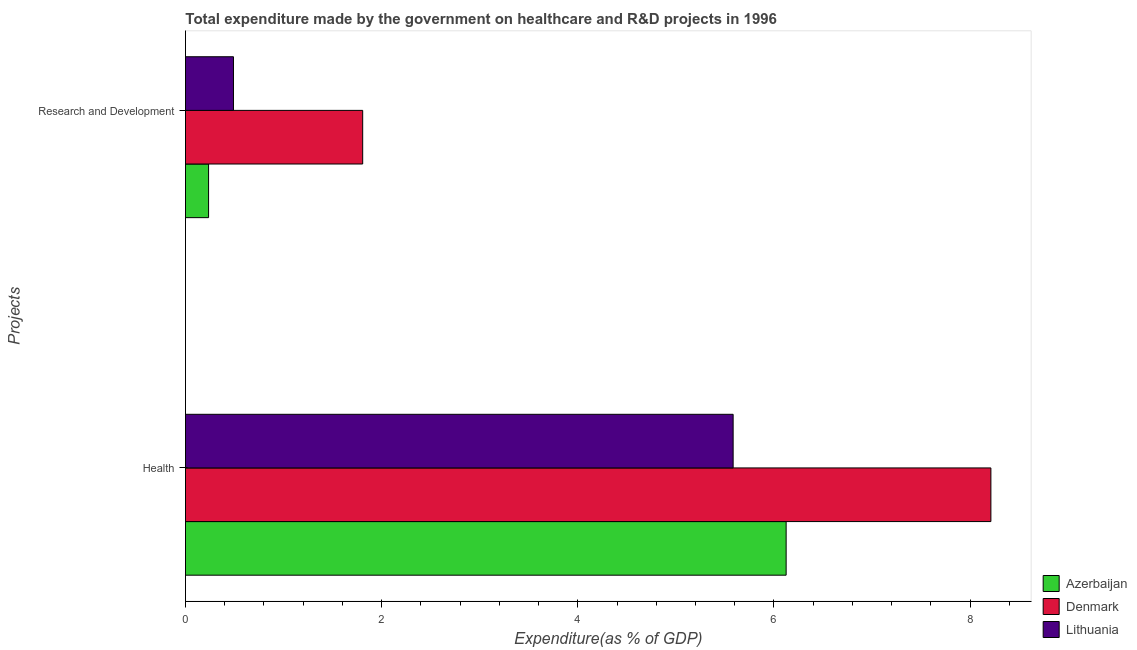How many different coloured bars are there?
Offer a very short reply. 3. Are the number of bars per tick equal to the number of legend labels?
Offer a very short reply. Yes. What is the label of the 2nd group of bars from the top?
Offer a very short reply. Health. What is the expenditure in r&d in Azerbaijan?
Offer a terse response. 0.24. Across all countries, what is the maximum expenditure in r&d?
Your answer should be compact. 1.81. Across all countries, what is the minimum expenditure in healthcare?
Provide a short and direct response. 5.58. In which country was the expenditure in healthcare maximum?
Make the answer very short. Denmark. In which country was the expenditure in r&d minimum?
Your answer should be compact. Azerbaijan. What is the total expenditure in r&d in the graph?
Your answer should be compact. 2.53. What is the difference between the expenditure in r&d in Lithuania and that in Azerbaijan?
Offer a terse response. 0.25. What is the difference between the expenditure in r&d in Lithuania and the expenditure in healthcare in Azerbaijan?
Your answer should be compact. -5.63. What is the average expenditure in r&d per country?
Provide a succinct answer. 0.84. What is the difference between the expenditure in r&d and expenditure in healthcare in Lithuania?
Keep it short and to the point. -5.09. In how many countries, is the expenditure in r&d greater than 2.8 %?
Your answer should be compact. 0. What is the ratio of the expenditure in r&d in Azerbaijan to that in Lithuania?
Your answer should be compact. 0.48. Is the expenditure in r&d in Denmark less than that in Azerbaijan?
Keep it short and to the point. No. In how many countries, is the expenditure in healthcare greater than the average expenditure in healthcare taken over all countries?
Your answer should be compact. 1. What does the 1st bar from the top in Health represents?
Your response must be concise. Lithuania. What is the difference between two consecutive major ticks on the X-axis?
Your answer should be compact. 2. Does the graph contain grids?
Give a very brief answer. No. Where does the legend appear in the graph?
Your answer should be compact. Bottom right. How many legend labels are there?
Keep it short and to the point. 3. How are the legend labels stacked?
Your answer should be very brief. Vertical. What is the title of the graph?
Provide a short and direct response. Total expenditure made by the government on healthcare and R&D projects in 1996. Does "Peru" appear as one of the legend labels in the graph?
Your answer should be compact. No. What is the label or title of the X-axis?
Your answer should be very brief. Expenditure(as % of GDP). What is the label or title of the Y-axis?
Ensure brevity in your answer.  Projects. What is the Expenditure(as % of GDP) in Azerbaijan in Health?
Provide a succinct answer. 6.12. What is the Expenditure(as % of GDP) in Denmark in Health?
Provide a short and direct response. 8.21. What is the Expenditure(as % of GDP) of Lithuania in Health?
Keep it short and to the point. 5.58. What is the Expenditure(as % of GDP) in Azerbaijan in Research and Development?
Provide a short and direct response. 0.24. What is the Expenditure(as % of GDP) of Denmark in Research and Development?
Give a very brief answer. 1.81. What is the Expenditure(as % of GDP) in Lithuania in Research and Development?
Provide a short and direct response. 0.49. Across all Projects, what is the maximum Expenditure(as % of GDP) in Azerbaijan?
Provide a short and direct response. 6.12. Across all Projects, what is the maximum Expenditure(as % of GDP) in Denmark?
Make the answer very short. 8.21. Across all Projects, what is the maximum Expenditure(as % of GDP) in Lithuania?
Make the answer very short. 5.58. Across all Projects, what is the minimum Expenditure(as % of GDP) in Azerbaijan?
Your response must be concise. 0.24. Across all Projects, what is the minimum Expenditure(as % of GDP) in Denmark?
Your answer should be compact. 1.81. Across all Projects, what is the minimum Expenditure(as % of GDP) in Lithuania?
Your answer should be very brief. 0.49. What is the total Expenditure(as % of GDP) in Azerbaijan in the graph?
Your response must be concise. 6.36. What is the total Expenditure(as % of GDP) of Denmark in the graph?
Offer a terse response. 10.02. What is the total Expenditure(as % of GDP) in Lithuania in the graph?
Provide a short and direct response. 6.07. What is the difference between the Expenditure(as % of GDP) in Azerbaijan in Health and that in Research and Development?
Your answer should be very brief. 5.89. What is the difference between the Expenditure(as % of GDP) in Denmark in Health and that in Research and Development?
Your answer should be compact. 6.4. What is the difference between the Expenditure(as % of GDP) in Lithuania in Health and that in Research and Development?
Provide a succinct answer. 5.09. What is the difference between the Expenditure(as % of GDP) in Azerbaijan in Health and the Expenditure(as % of GDP) in Denmark in Research and Development?
Offer a very short reply. 4.32. What is the difference between the Expenditure(as % of GDP) of Azerbaijan in Health and the Expenditure(as % of GDP) of Lithuania in Research and Development?
Offer a terse response. 5.63. What is the difference between the Expenditure(as % of GDP) in Denmark in Health and the Expenditure(as % of GDP) in Lithuania in Research and Development?
Give a very brief answer. 7.72. What is the average Expenditure(as % of GDP) in Azerbaijan per Projects?
Make the answer very short. 3.18. What is the average Expenditure(as % of GDP) of Denmark per Projects?
Keep it short and to the point. 5.01. What is the average Expenditure(as % of GDP) of Lithuania per Projects?
Keep it short and to the point. 3.04. What is the difference between the Expenditure(as % of GDP) in Azerbaijan and Expenditure(as % of GDP) in Denmark in Health?
Offer a terse response. -2.09. What is the difference between the Expenditure(as % of GDP) of Azerbaijan and Expenditure(as % of GDP) of Lithuania in Health?
Keep it short and to the point. 0.54. What is the difference between the Expenditure(as % of GDP) in Denmark and Expenditure(as % of GDP) in Lithuania in Health?
Offer a terse response. 2.63. What is the difference between the Expenditure(as % of GDP) of Azerbaijan and Expenditure(as % of GDP) of Denmark in Research and Development?
Your response must be concise. -1.57. What is the difference between the Expenditure(as % of GDP) in Azerbaijan and Expenditure(as % of GDP) in Lithuania in Research and Development?
Make the answer very short. -0.25. What is the difference between the Expenditure(as % of GDP) of Denmark and Expenditure(as % of GDP) of Lithuania in Research and Development?
Provide a short and direct response. 1.32. What is the ratio of the Expenditure(as % of GDP) in Azerbaijan in Health to that in Research and Development?
Keep it short and to the point. 26.02. What is the ratio of the Expenditure(as % of GDP) of Denmark in Health to that in Research and Development?
Give a very brief answer. 4.55. What is the ratio of the Expenditure(as % of GDP) in Lithuania in Health to that in Research and Development?
Keep it short and to the point. 11.41. What is the difference between the highest and the second highest Expenditure(as % of GDP) of Azerbaijan?
Ensure brevity in your answer.  5.89. What is the difference between the highest and the second highest Expenditure(as % of GDP) of Denmark?
Your answer should be very brief. 6.4. What is the difference between the highest and the second highest Expenditure(as % of GDP) of Lithuania?
Give a very brief answer. 5.09. What is the difference between the highest and the lowest Expenditure(as % of GDP) of Azerbaijan?
Keep it short and to the point. 5.89. What is the difference between the highest and the lowest Expenditure(as % of GDP) in Denmark?
Give a very brief answer. 6.4. What is the difference between the highest and the lowest Expenditure(as % of GDP) in Lithuania?
Make the answer very short. 5.09. 